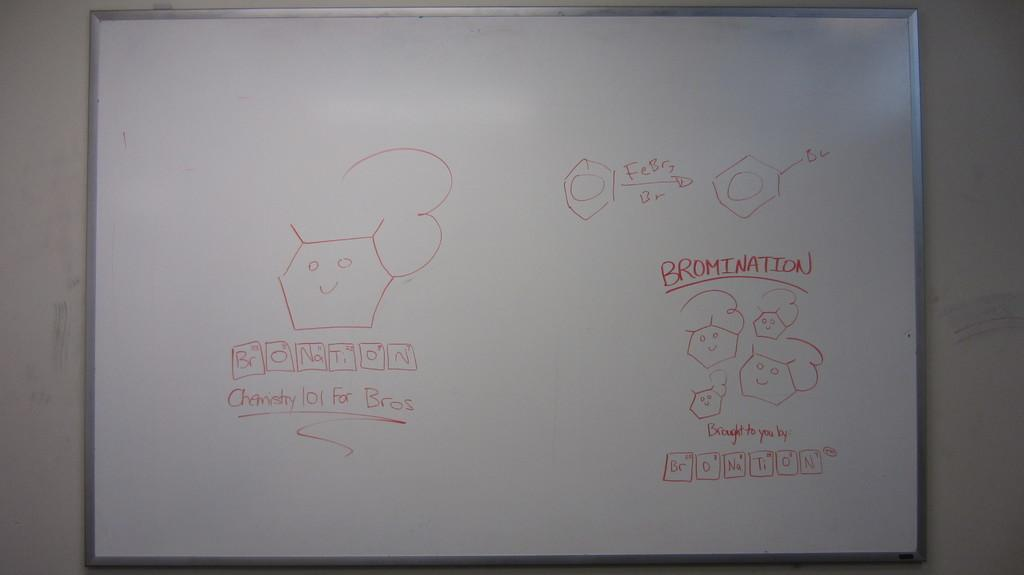<image>
Summarize the visual content of the image. White board that has the word "Bromination" in red. 